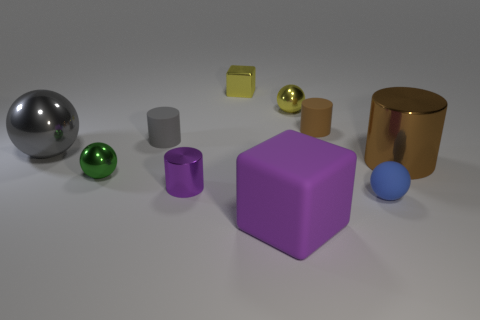Subtract all brown balls. Subtract all red cubes. How many balls are left? 4 Subtract all balls. How many objects are left? 6 Subtract all purple shiny objects. Subtract all rubber cylinders. How many objects are left? 7 Add 8 tiny metal cylinders. How many tiny metal cylinders are left? 9 Add 5 large rubber things. How many large rubber things exist? 6 Subtract 1 purple blocks. How many objects are left? 9 